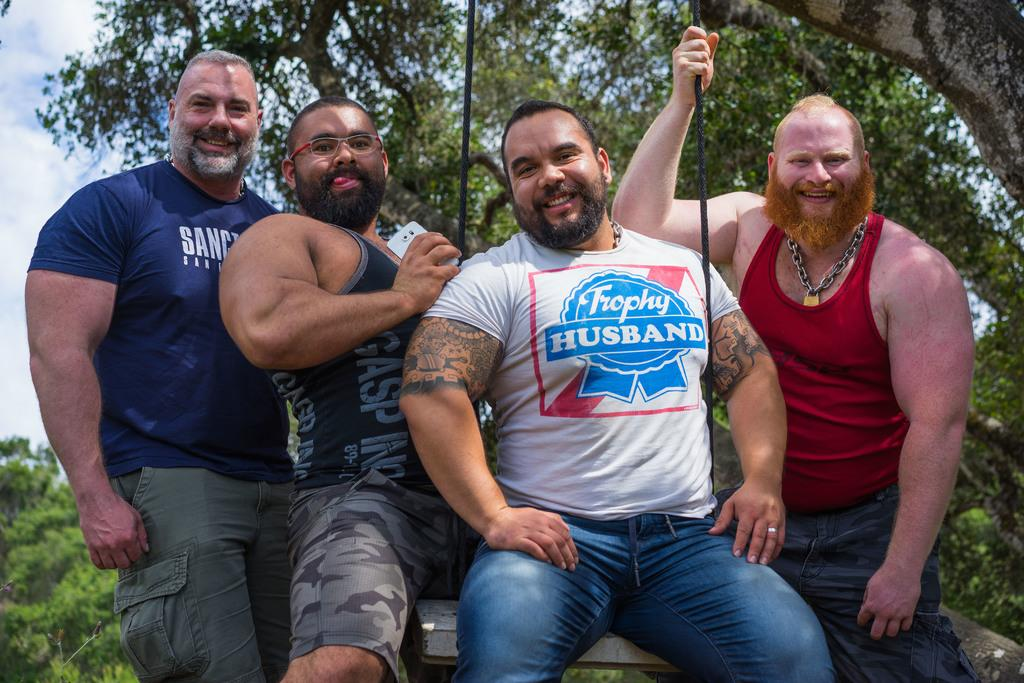How many people are in the image? There are four persons in the image. What is one person doing in the image? One person is sitting on a cradle. How is the cradle secured? The cradle is tied to a tree. What are the other three persons doing in the image? The other three persons are standing beside the person sitting on the cradle. What flavor of ice cream is being enjoyed by the person sitting on the cradle? There is no ice cream present in the image, so it is not possible to determine the flavor being enjoyed. 